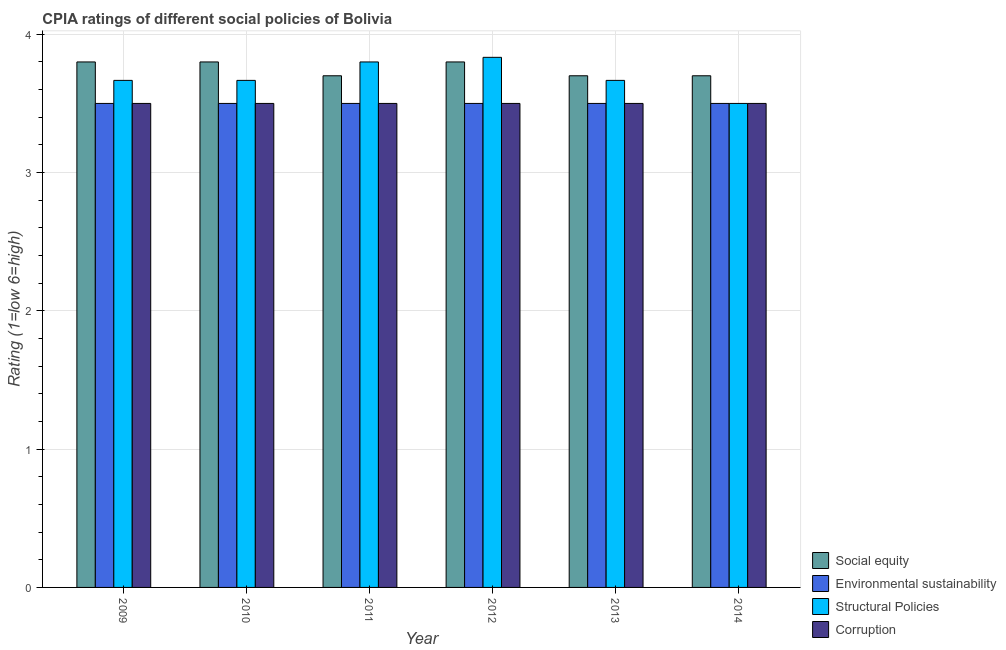How many different coloured bars are there?
Make the answer very short. 4. How many groups of bars are there?
Provide a succinct answer. 6. Are the number of bars per tick equal to the number of legend labels?
Keep it short and to the point. Yes. How many bars are there on the 4th tick from the right?
Provide a short and direct response. 4. What is the label of the 1st group of bars from the left?
Ensure brevity in your answer.  2009. In how many cases, is the number of bars for a given year not equal to the number of legend labels?
Offer a terse response. 0. What is the cpia rating of corruption in 2011?
Your answer should be compact. 3.5. What is the total cpia rating of corruption in the graph?
Provide a short and direct response. 21. What is the average cpia rating of structural policies per year?
Your answer should be very brief. 3.69. In the year 2009, what is the difference between the cpia rating of social equity and cpia rating of structural policies?
Provide a short and direct response. 0. In how many years, is the cpia rating of environmental sustainability greater than 2.6?
Give a very brief answer. 6. Is the cpia rating of social equity in 2011 less than that in 2012?
Keep it short and to the point. Yes. What is the difference between the highest and the second highest cpia rating of environmental sustainability?
Make the answer very short. 0. What is the difference between the highest and the lowest cpia rating of social equity?
Provide a short and direct response. 0.1. What does the 3rd bar from the left in 2010 represents?
Offer a very short reply. Structural Policies. What does the 2nd bar from the right in 2013 represents?
Offer a terse response. Structural Policies. Are all the bars in the graph horizontal?
Offer a very short reply. No. What is the difference between two consecutive major ticks on the Y-axis?
Ensure brevity in your answer.  1. What is the title of the graph?
Make the answer very short. CPIA ratings of different social policies of Bolivia. Does "Coal" appear as one of the legend labels in the graph?
Ensure brevity in your answer.  No. What is the label or title of the X-axis?
Your response must be concise. Year. What is the label or title of the Y-axis?
Keep it short and to the point. Rating (1=low 6=high). What is the Rating (1=low 6=high) of Social equity in 2009?
Offer a terse response. 3.8. What is the Rating (1=low 6=high) in Structural Policies in 2009?
Your response must be concise. 3.67. What is the Rating (1=low 6=high) of Social equity in 2010?
Ensure brevity in your answer.  3.8. What is the Rating (1=low 6=high) of Environmental sustainability in 2010?
Provide a short and direct response. 3.5. What is the Rating (1=low 6=high) of Structural Policies in 2010?
Give a very brief answer. 3.67. What is the Rating (1=low 6=high) of Environmental sustainability in 2011?
Your answer should be compact. 3.5. What is the Rating (1=low 6=high) of Corruption in 2011?
Keep it short and to the point. 3.5. What is the Rating (1=low 6=high) of Social equity in 2012?
Give a very brief answer. 3.8. What is the Rating (1=low 6=high) in Structural Policies in 2012?
Offer a terse response. 3.83. What is the Rating (1=low 6=high) in Corruption in 2012?
Provide a short and direct response. 3.5. What is the Rating (1=low 6=high) in Structural Policies in 2013?
Your response must be concise. 3.67. What is the Rating (1=low 6=high) of Corruption in 2013?
Offer a very short reply. 3.5. What is the Rating (1=low 6=high) in Environmental sustainability in 2014?
Your response must be concise. 3.5. What is the Rating (1=low 6=high) in Corruption in 2014?
Ensure brevity in your answer.  3.5. Across all years, what is the maximum Rating (1=low 6=high) of Structural Policies?
Provide a succinct answer. 3.83. Across all years, what is the maximum Rating (1=low 6=high) in Corruption?
Give a very brief answer. 3.5. What is the total Rating (1=low 6=high) of Social equity in the graph?
Your answer should be very brief. 22.5. What is the total Rating (1=low 6=high) of Environmental sustainability in the graph?
Ensure brevity in your answer.  21. What is the total Rating (1=low 6=high) of Structural Policies in the graph?
Offer a terse response. 22.13. What is the difference between the Rating (1=low 6=high) of Environmental sustainability in 2009 and that in 2010?
Give a very brief answer. 0. What is the difference between the Rating (1=low 6=high) in Structural Policies in 2009 and that in 2010?
Your answer should be very brief. 0. What is the difference between the Rating (1=low 6=high) of Corruption in 2009 and that in 2010?
Give a very brief answer. 0. What is the difference between the Rating (1=low 6=high) of Social equity in 2009 and that in 2011?
Make the answer very short. 0.1. What is the difference between the Rating (1=low 6=high) in Environmental sustainability in 2009 and that in 2011?
Ensure brevity in your answer.  0. What is the difference between the Rating (1=low 6=high) in Structural Policies in 2009 and that in 2011?
Your answer should be very brief. -0.13. What is the difference between the Rating (1=low 6=high) in Social equity in 2009 and that in 2012?
Your answer should be compact. 0. What is the difference between the Rating (1=low 6=high) in Environmental sustainability in 2009 and that in 2012?
Provide a short and direct response. 0. What is the difference between the Rating (1=low 6=high) of Corruption in 2009 and that in 2012?
Offer a very short reply. 0. What is the difference between the Rating (1=low 6=high) of Social equity in 2009 and that in 2013?
Offer a very short reply. 0.1. What is the difference between the Rating (1=low 6=high) of Environmental sustainability in 2009 and that in 2013?
Offer a terse response. 0. What is the difference between the Rating (1=low 6=high) in Structural Policies in 2009 and that in 2014?
Keep it short and to the point. 0.17. What is the difference between the Rating (1=low 6=high) of Corruption in 2009 and that in 2014?
Provide a succinct answer. 0. What is the difference between the Rating (1=low 6=high) in Social equity in 2010 and that in 2011?
Ensure brevity in your answer.  0.1. What is the difference between the Rating (1=low 6=high) in Structural Policies in 2010 and that in 2011?
Offer a terse response. -0.13. What is the difference between the Rating (1=low 6=high) of Structural Policies in 2010 and that in 2012?
Offer a terse response. -0.17. What is the difference between the Rating (1=low 6=high) in Corruption in 2010 and that in 2012?
Make the answer very short. 0. What is the difference between the Rating (1=low 6=high) in Social equity in 2010 and that in 2013?
Give a very brief answer. 0.1. What is the difference between the Rating (1=low 6=high) of Structural Policies in 2010 and that in 2013?
Give a very brief answer. 0. What is the difference between the Rating (1=low 6=high) of Corruption in 2010 and that in 2013?
Your response must be concise. 0. What is the difference between the Rating (1=low 6=high) of Environmental sustainability in 2010 and that in 2014?
Your response must be concise. 0. What is the difference between the Rating (1=low 6=high) in Environmental sustainability in 2011 and that in 2012?
Provide a short and direct response. 0. What is the difference between the Rating (1=low 6=high) of Structural Policies in 2011 and that in 2012?
Offer a very short reply. -0.03. What is the difference between the Rating (1=low 6=high) of Social equity in 2011 and that in 2013?
Make the answer very short. 0. What is the difference between the Rating (1=low 6=high) in Structural Policies in 2011 and that in 2013?
Your answer should be very brief. 0.13. What is the difference between the Rating (1=low 6=high) in Social equity in 2011 and that in 2014?
Your answer should be very brief. 0. What is the difference between the Rating (1=low 6=high) in Structural Policies in 2011 and that in 2014?
Your response must be concise. 0.3. What is the difference between the Rating (1=low 6=high) in Structural Policies in 2012 and that in 2013?
Your response must be concise. 0.17. What is the difference between the Rating (1=low 6=high) of Corruption in 2012 and that in 2013?
Ensure brevity in your answer.  0. What is the difference between the Rating (1=low 6=high) in Structural Policies in 2012 and that in 2014?
Your response must be concise. 0.33. What is the difference between the Rating (1=low 6=high) in Corruption in 2012 and that in 2014?
Offer a terse response. 0. What is the difference between the Rating (1=low 6=high) in Social equity in 2013 and that in 2014?
Your response must be concise. 0. What is the difference between the Rating (1=low 6=high) of Social equity in 2009 and the Rating (1=low 6=high) of Structural Policies in 2010?
Give a very brief answer. 0.13. What is the difference between the Rating (1=low 6=high) in Environmental sustainability in 2009 and the Rating (1=low 6=high) in Corruption in 2010?
Provide a short and direct response. 0. What is the difference between the Rating (1=low 6=high) of Social equity in 2009 and the Rating (1=low 6=high) of Structural Policies in 2011?
Keep it short and to the point. 0. What is the difference between the Rating (1=low 6=high) of Social equity in 2009 and the Rating (1=low 6=high) of Corruption in 2011?
Keep it short and to the point. 0.3. What is the difference between the Rating (1=low 6=high) of Structural Policies in 2009 and the Rating (1=low 6=high) of Corruption in 2011?
Ensure brevity in your answer.  0.17. What is the difference between the Rating (1=low 6=high) of Social equity in 2009 and the Rating (1=low 6=high) of Environmental sustainability in 2012?
Your answer should be very brief. 0.3. What is the difference between the Rating (1=low 6=high) of Social equity in 2009 and the Rating (1=low 6=high) of Structural Policies in 2012?
Keep it short and to the point. -0.03. What is the difference between the Rating (1=low 6=high) of Social equity in 2009 and the Rating (1=low 6=high) of Corruption in 2012?
Your response must be concise. 0.3. What is the difference between the Rating (1=low 6=high) of Environmental sustainability in 2009 and the Rating (1=low 6=high) of Structural Policies in 2012?
Your answer should be compact. -0.33. What is the difference between the Rating (1=low 6=high) of Environmental sustainability in 2009 and the Rating (1=low 6=high) of Corruption in 2012?
Provide a short and direct response. 0. What is the difference between the Rating (1=low 6=high) of Social equity in 2009 and the Rating (1=low 6=high) of Environmental sustainability in 2013?
Give a very brief answer. 0.3. What is the difference between the Rating (1=low 6=high) of Social equity in 2009 and the Rating (1=low 6=high) of Structural Policies in 2013?
Your response must be concise. 0.13. What is the difference between the Rating (1=low 6=high) in Social equity in 2009 and the Rating (1=low 6=high) in Corruption in 2013?
Provide a short and direct response. 0.3. What is the difference between the Rating (1=low 6=high) in Environmental sustainability in 2009 and the Rating (1=low 6=high) in Structural Policies in 2013?
Your answer should be very brief. -0.17. What is the difference between the Rating (1=low 6=high) of Structural Policies in 2009 and the Rating (1=low 6=high) of Corruption in 2013?
Your answer should be compact. 0.17. What is the difference between the Rating (1=low 6=high) in Social equity in 2009 and the Rating (1=low 6=high) in Environmental sustainability in 2014?
Ensure brevity in your answer.  0.3. What is the difference between the Rating (1=low 6=high) of Social equity in 2009 and the Rating (1=low 6=high) of Structural Policies in 2014?
Ensure brevity in your answer.  0.3. What is the difference between the Rating (1=low 6=high) in Environmental sustainability in 2009 and the Rating (1=low 6=high) in Corruption in 2014?
Give a very brief answer. 0. What is the difference between the Rating (1=low 6=high) of Social equity in 2010 and the Rating (1=low 6=high) of Structural Policies in 2011?
Give a very brief answer. 0. What is the difference between the Rating (1=low 6=high) of Environmental sustainability in 2010 and the Rating (1=low 6=high) of Structural Policies in 2011?
Offer a terse response. -0.3. What is the difference between the Rating (1=low 6=high) of Structural Policies in 2010 and the Rating (1=low 6=high) of Corruption in 2011?
Your answer should be very brief. 0.17. What is the difference between the Rating (1=low 6=high) in Social equity in 2010 and the Rating (1=low 6=high) in Environmental sustainability in 2012?
Your answer should be compact. 0.3. What is the difference between the Rating (1=low 6=high) in Social equity in 2010 and the Rating (1=low 6=high) in Structural Policies in 2012?
Offer a terse response. -0.03. What is the difference between the Rating (1=low 6=high) in Structural Policies in 2010 and the Rating (1=low 6=high) in Corruption in 2012?
Offer a terse response. 0.17. What is the difference between the Rating (1=low 6=high) of Social equity in 2010 and the Rating (1=low 6=high) of Structural Policies in 2013?
Give a very brief answer. 0.13. What is the difference between the Rating (1=low 6=high) of Environmental sustainability in 2010 and the Rating (1=low 6=high) of Structural Policies in 2013?
Offer a very short reply. -0.17. What is the difference between the Rating (1=low 6=high) of Social equity in 2010 and the Rating (1=low 6=high) of Environmental sustainability in 2014?
Your answer should be compact. 0.3. What is the difference between the Rating (1=low 6=high) in Social equity in 2010 and the Rating (1=low 6=high) in Structural Policies in 2014?
Your response must be concise. 0.3. What is the difference between the Rating (1=low 6=high) of Social equity in 2010 and the Rating (1=low 6=high) of Corruption in 2014?
Your answer should be very brief. 0.3. What is the difference between the Rating (1=low 6=high) of Environmental sustainability in 2010 and the Rating (1=low 6=high) of Corruption in 2014?
Your response must be concise. 0. What is the difference between the Rating (1=low 6=high) of Social equity in 2011 and the Rating (1=low 6=high) of Environmental sustainability in 2012?
Ensure brevity in your answer.  0.2. What is the difference between the Rating (1=low 6=high) of Social equity in 2011 and the Rating (1=low 6=high) of Structural Policies in 2012?
Give a very brief answer. -0.13. What is the difference between the Rating (1=low 6=high) of Social equity in 2011 and the Rating (1=low 6=high) of Corruption in 2012?
Your response must be concise. 0.2. What is the difference between the Rating (1=low 6=high) in Environmental sustainability in 2011 and the Rating (1=low 6=high) in Structural Policies in 2012?
Offer a terse response. -0.33. What is the difference between the Rating (1=low 6=high) in Environmental sustainability in 2011 and the Rating (1=low 6=high) in Corruption in 2013?
Provide a succinct answer. 0. What is the difference between the Rating (1=low 6=high) of Structural Policies in 2011 and the Rating (1=low 6=high) of Corruption in 2014?
Provide a succinct answer. 0.3. What is the difference between the Rating (1=low 6=high) in Social equity in 2012 and the Rating (1=low 6=high) in Environmental sustainability in 2013?
Provide a short and direct response. 0.3. What is the difference between the Rating (1=low 6=high) of Social equity in 2012 and the Rating (1=low 6=high) of Structural Policies in 2013?
Keep it short and to the point. 0.13. What is the difference between the Rating (1=low 6=high) of Social equity in 2012 and the Rating (1=low 6=high) of Corruption in 2013?
Offer a terse response. 0.3. What is the difference between the Rating (1=low 6=high) in Social equity in 2012 and the Rating (1=low 6=high) in Structural Policies in 2014?
Ensure brevity in your answer.  0.3. What is the difference between the Rating (1=low 6=high) in Environmental sustainability in 2012 and the Rating (1=low 6=high) in Structural Policies in 2014?
Make the answer very short. 0. What is the difference between the Rating (1=low 6=high) in Structural Policies in 2012 and the Rating (1=low 6=high) in Corruption in 2014?
Offer a terse response. 0.33. What is the difference between the Rating (1=low 6=high) in Social equity in 2013 and the Rating (1=low 6=high) in Environmental sustainability in 2014?
Make the answer very short. 0.2. What is the difference between the Rating (1=low 6=high) of Social equity in 2013 and the Rating (1=low 6=high) of Structural Policies in 2014?
Provide a succinct answer. 0.2. What is the difference between the Rating (1=low 6=high) of Environmental sustainability in 2013 and the Rating (1=low 6=high) of Structural Policies in 2014?
Make the answer very short. 0. What is the difference between the Rating (1=low 6=high) in Environmental sustainability in 2013 and the Rating (1=low 6=high) in Corruption in 2014?
Offer a very short reply. 0. What is the difference between the Rating (1=low 6=high) in Structural Policies in 2013 and the Rating (1=low 6=high) in Corruption in 2014?
Your answer should be compact. 0.17. What is the average Rating (1=low 6=high) in Social equity per year?
Provide a short and direct response. 3.75. What is the average Rating (1=low 6=high) in Structural Policies per year?
Provide a short and direct response. 3.69. What is the average Rating (1=low 6=high) of Corruption per year?
Give a very brief answer. 3.5. In the year 2009, what is the difference between the Rating (1=low 6=high) in Social equity and Rating (1=low 6=high) in Structural Policies?
Your answer should be compact. 0.13. In the year 2009, what is the difference between the Rating (1=low 6=high) in Social equity and Rating (1=low 6=high) in Corruption?
Make the answer very short. 0.3. In the year 2009, what is the difference between the Rating (1=low 6=high) in Environmental sustainability and Rating (1=low 6=high) in Corruption?
Your answer should be very brief. 0. In the year 2009, what is the difference between the Rating (1=low 6=high) in Structural Policies and Rating (1=low 6=high) in Corruption?
Ensure brevity in your answer.  0.17. In the year 2010, what is the difference between the Rating (1=low 6=high) in Social equity and Rating (1=low 6=high) in Environmental sustainability?
Provide a short and direct response. 0.3. In the year 2010, what is the difference between the Rating (1=low 6=high) of Social equity and Rating (1=low 6=high) of Structural Policies?
Your answer should be compact. 0.13. In the year 2010, what is the difference between the Rating (1=low 6=high) in Environmental sustainability and Rating (1=low 6=high) in Structural Policies?
Ensure brevity in your answer.  -0.17. In the year 2010, what is the difference between the Rating (1=low 6=high) of Environmental sustainability and Rating (1=low 6=high) of Corruption?
Ensure brevity in your answer.  0. In the year 2010, what is the difference between the Rating (1=low 6=high) in Structural Policies and Rating (1=low 6=high) in Corruption?
Give a very brief answer. 0.17. In the year 2011, what is the difference between the Rating (1=low 6=high) of Social equity and Rating (1=low 6=high) of Structural Policies?
Ensure brevity in your answer.  -0.1. In the year 2011, what is the difference between the Rating (1=low 6=high) of Social equity and Rating (1=low 6=high) of Corruption?
Your response must be concise. 0.2. In the year 2011, what is the difference between the Rating (1=low 6=high) of Environmental sustainability and Rating (1=low 6=high) of Corruption?
Give a very brief answer. 0. In the year 2011, what is the difference between the Rating (1=low 6=high) of Structural Policies and Rating (1=low 6=high) of Corruption?
Provide a short and direct response. 0.3. In the year 2012, what is the difference between the Rating (1=low 6=high) in Social equity and Rating (1=low 6=high) in Environmental sustainability?
Provide a short and direct response. 0.3. In the year 2012, what is the difference between the Rating (1=low 6=high) in Social equity and Rating (1=low 6=high) in Structural Policies?
Make the answer very short. -0.03. In the year 2012, what is the difference between the Rating (1=low 6=high) in Social equity and Rating (1=low 6=high) in Corruption?
Make the answer very short. 0.3. In the year 2012, what is the difference between the Rating (1=low 6=high) of Environmental sustainability and Rating (1=low 6=high) of Structural Policies?
Give a very brief answer. -0.33. In the year 2013, what is the difference between the Rating (1=low 6=high) in Social equity and Rating (1=low 6=high) in Environmental sustainability?
Ensure brevity in your answer.  0.2. In the year 2013, what is the difference between the Rating (1=low 6=high) of Social equity and Rating (1=low 6=high) of Corruption?
Ensure brevity in your answer.  0.2. In the year 2014, what is the difference between the Rating (1=low 6=high) in Social equity and Rating (1=low 6=high) in Environmental sustainability?
Your answer should be very brief. 0.2. In the year 2014, what is the difference between the Rating (1=low 6=high) in Social equity and Rating (1=low 6=high) in Structural Policies?
Offer a very short reply. 0.2. In the year 2014, what is the difference between the Rating (1=low 6=high) of Environmental sustainability and Rating (1=low 6=high) of Corruption?
Your answer should be very brief. 0. In the year 2014, what is the difference between the Rating (1=low 6=high) in Structural Policies and Rating (1=low 6=high) in Corruption?
Offer a terse response. 0. What is the ratio of the Rating (1=low 6=high) of Social equity in 2009 to that in 2011?
Offer a very short reply. 1.03. What is the ratio of the Rating (1=low 6=high) of Environmental sustainability in 2009 to that in 2011?
Offer a terse response. 1. What is the ratio of the Rating (1=low 6=high) in Structural Policies in 2009 to that in 2011?
Provide a succinct answer. 0.96. What is the ratio of the Rating (1=low 6=high) of Corruption in 2009 to that in 2011?
Give a very brief answer. 1. What is the ratio of the Rating (1=low 6=high) of Structural Policies in 2009 to that in 2012?
Your answer should be very brief. 0.96. What is the ratio of the Rating (1=low 6=high) of Social equity in 2009 to that in 2013?
Keep it short and to the point. 1.03. What is the ratio of the Rating (1=low 6=high) of Environmental sustainability in 2009 to that in 2013?
Ensure brevity in your answer.  1. What is the ratio of the Rating (1=low 6=high) of Structural Policies in 2009 to that in 2013?
Give a very brief answer. 1. What is the ratio of the Rating (1=low 6=high) of Corruption in 2009 to that in 2013?
Make the answer very short. 1. What is the ratio of the Rating (1=low 6=high) of Social equity in 2009 to that in 2014?
Provide a succinct answer. 1.03. What is the ratio of the Rating (1=low 6=high) of Structural Policies in 2009 to that in 2014?
Offer a terse response. 1.05. What is the ratio of the Rating (1=low 6=high) in Corruption in 2009 to that in 2014?
Your answer should be very brief. 1. What is the ratio of the Rating (1=low 6=high) in Social equity in 2010 to that in 2011?
Provide a short and direct response. 1.03. What is the ratio of the Rating (1=low 6=high) of Structural Policies in 2010 to that in 2011?
Your response must be concise. 0.96. What is the ratio of the Rating (1=low 6=high) of Social equity in 2010 to that in 2012?
Your response must be concise. 1. What is the ratio of the Rating (1=low 6=high) in Structural Policies in 2010 to that in 2012?
Your answer should be compact. 0.96. What is the ratio of the Rating (1=low 6=high) in Social equity in 2010 to that in 2013?
Your answer should be compact. 1.03. What is the ratio of the Rating (1=low 6=high) in Structural Policies in 2010 to that in 2013?
Your answer should be very brief. 1. What is the ratio of the Rating (1=low 6=high) in Social equity in 2010 to that in 2014?
Provide a succinct answer. 1.03. What is the ratio of the Rating (1=low 6=high) in Environmental sustainability in 2010 to that in 2014?
Ensure brevity in your answer.  1. What is the ratio of the Rating (1=low 6=high) of Structural Policies in 2010 to that in 2014?
Give a very brief answer. 1.05. What is the ratio of the Rating (1=low 6=high) of Social equity in 2011 to that in 2012?
Offer a terse response. 0.97. What is the ratio of the Rating (1=low 6=high) of Structural Policies in 2011 to that in 2012?
Offer a very short reply. 0.99. What is the ratio of the Rating (1=low 6=high) of Corruption in 2011 to that in 2012?
Your response must be concise. 1. What is the ratio of the Rating (1=low 6=high) of Social equity in 2011 to that in 2013?
Your response must be concise. 1. What is the ratio of the Rating (1=low 6=high) in Structural Policies in 2011 to that in 2013?
Your answer should be compact. 1.04. What is the ratio of the Rating (1=low 6=high) of Corruption in 2011 to that in 2013?
Provide a short and direct response. 1. What is the ratio of the Rating (1=low 6=high) in Social equity in 2011 to that in 2014?
Offer a very short reply. 1. What is the ratio of the Rating (1=low 6=high) in Structural Policies in 2011 to that in 2014?
Keep it short and to the point. 1.09. What is the ratio of the Rating (1=low 6=high) of Corruption in 2011 to that in 2014?
Provide a succinct answer. 1. What is the ratio of the Rating (1=low 6=high) of Structural Policies in 2012 to that in 2013?
Provide a succinct answer. 1.05. What is the ratio of the Rating (1=low 6=high) of Corruption in 2012 to that in 2013?
Ensure brevity in your answer.  1. What is the ratio of the Rating (1=low 6=high) of Social equity in 2012 to that in 2014?
Offer a terse response. 1.03. What is the ratio of the Rating (1=low 6=high) in Environmental sustainability in 2012 to that in 2014?
Offer a very short reply. 1. What is the ratio of the Rating (1=low 6=high) of Structural Policies in 2012 to that in 2014?
Keep it short and to the point. 1.1. What is the ratio of the Rating (1=low 6=high) of Social equity in 2013 to that in 2014?
Offer a very short reply. 1. What is the ratio of the Rating (1=low 6=high) in Structural Policies in 2013 to that in 2014?
Keep it short and to the point. 1.05. What is the ratio of the Rating (1=low 6=high) in Corruption in 2013 to that in 2014?
Ensure brevity in your answer.  1. What is the difference between the highest and the lowest Rating (1=low 6=high) of Social equity?
Keep it short and to the point. 0.1. What is the difference between the highest and the lowest Rating (1=low 6=high) in Structural Policies?
Offer a very short reply. 0.33. 